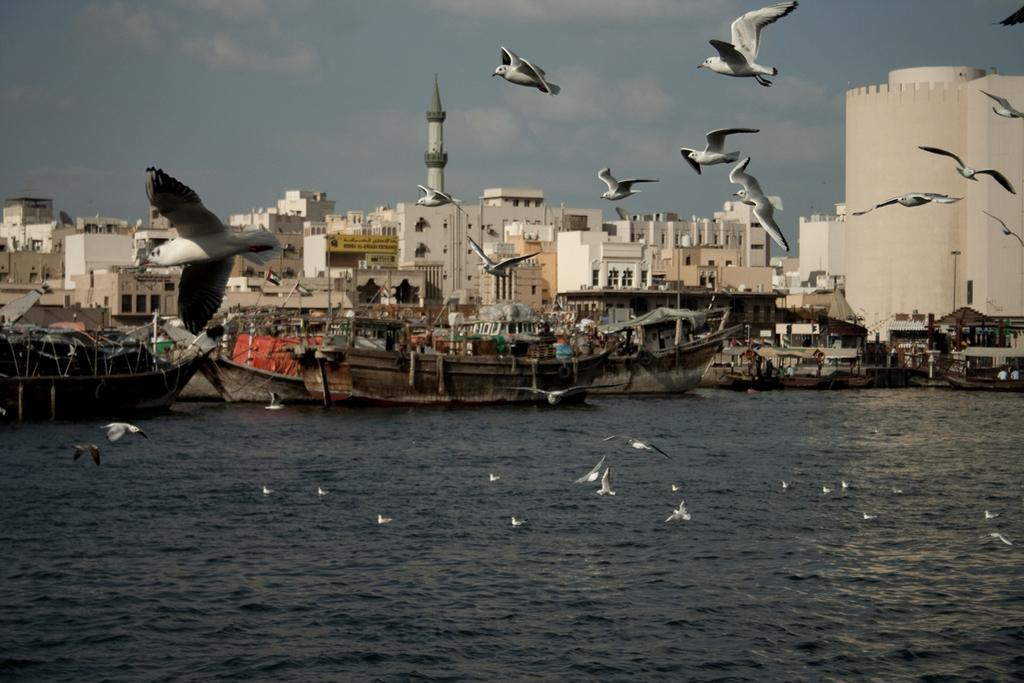What is located at the bottom of the image? There is water at the bottom of the image. What can be seen in the middle of the image? Birds are flying in the middle of the image. What type of vehicles are present in the image? Ships are present in the image. What type of structures are visible in the image? Buildings are visible in the image. What is visible at the top of the image? The sky is visible at the top of the image. How does the pest affect the ships in the image? There is no pest present in the image, so it cannot affect the ships. What type of vessel is used by the birds to fly in the image? The birds are not using any vessels to fly in the image; they are flying naturally. 